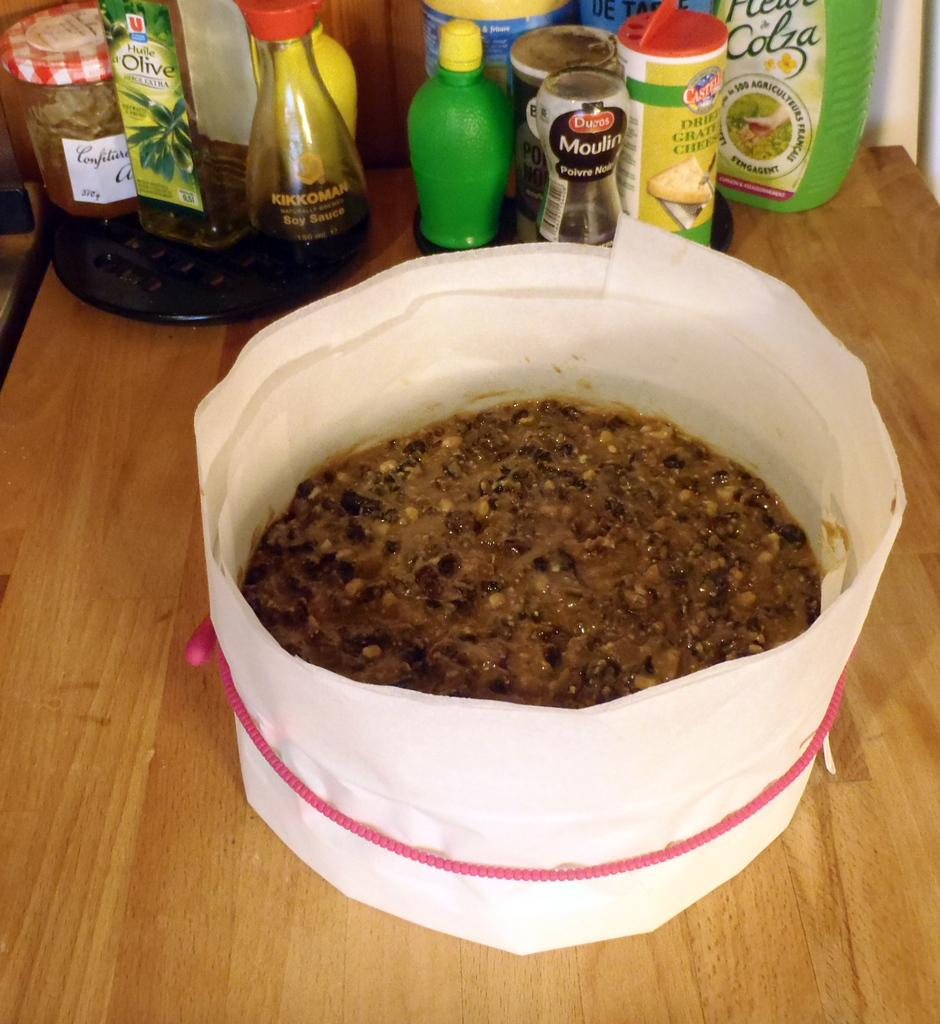What type of furniture is present in the image? There is a table in the image. What items are placed on the table? There are bottles, plastic boxes, and a pie on the table. What might be used for cleaning or wiping in the image? Tissues are placed around the pie. Are there any babies in the image who are slipping on the pie? There are no babies present in the image, and therefore no slipping can be observed. 